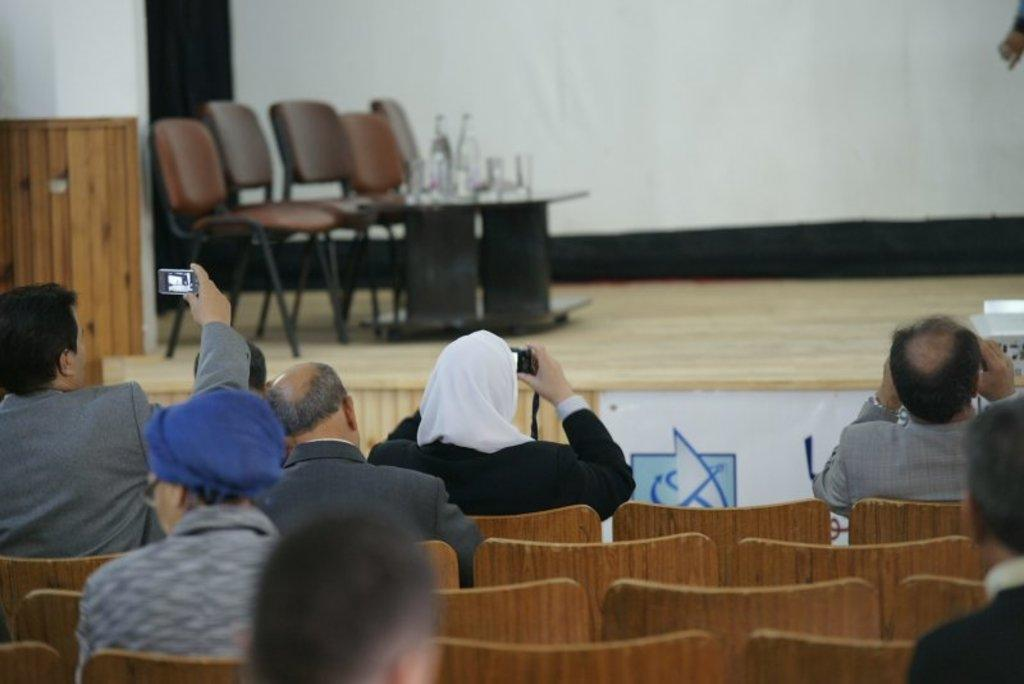What are the people in the image doing? The people in the image are sitting on chairs. What objects are the people holding in their hands? The people are holding cameras in their hands. Where are the chairs located in the image? The chairs are on the stage in the image. What other object is present on the stage? There is a table on the stage in the image. What type of lamp is being used as an attraction in the image? There is no lamp or attraction present in the image; it features people sitting on chairs and holding cameras on a stage with a table. 